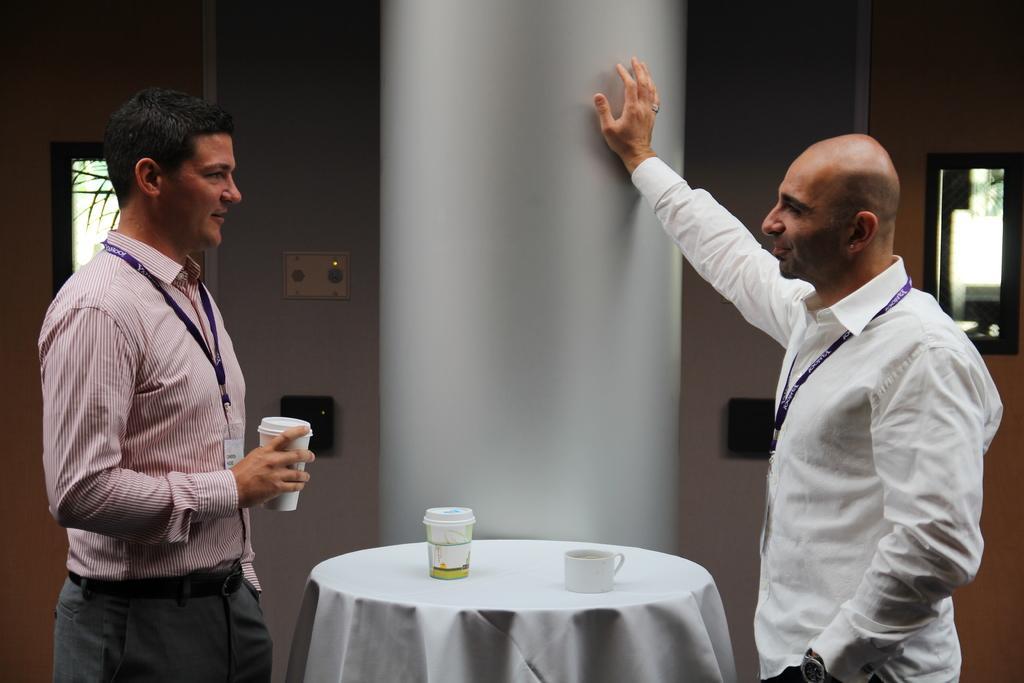Could you give a brief overview of what you see in this image? This image consists of two persons and a table between them. There are two cups on the table, the one on the right side is wearing white dress. Behind him there is a mirror sorry there is a window. 